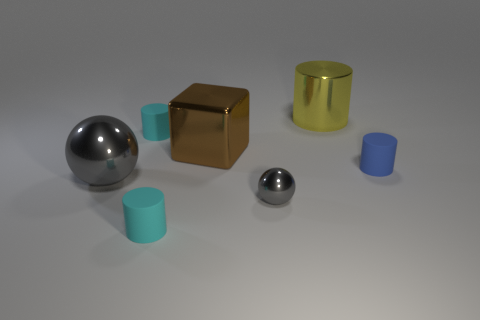Do the gray metal thing on the left side of the small ball and the thing on the right side of the yellow cylinder have the same size?
Provide a short and direct response. No. How many shiny blocks are the same color as the large sphere?
Your answer should be very brief. 0. How many large objects are shiny balls or brown metallic cubes?
Provide a short and direct response. 2. Do the cyan cylinder that is in front of the big sphere and the block have the same material?
Make the answer very short. No. There is a big object in front of the blue cylinder; what is its color?
Provide a succinct answer. Gray. Is there a gray sphere that has the same size as the brown metallic cube?
Your response must be concise. Yes. What is the material of the yellow cylinder that is the same size as the brown metal object?
Give a very brief answer. Metal. There is a blue cylinder; is its size the same as the cyan cylinder that is in front of the blue cylinder?
Provide a succinct answer. Yes. There is a cyan thing that is in front of the tiny blue rubber thing; what material is it?
Your response must be concise. Rubber. Is the number of cyan cylinders that are in front of the big brown cube the same as the number of large green cubes?
Your answer should be very brief. No. 